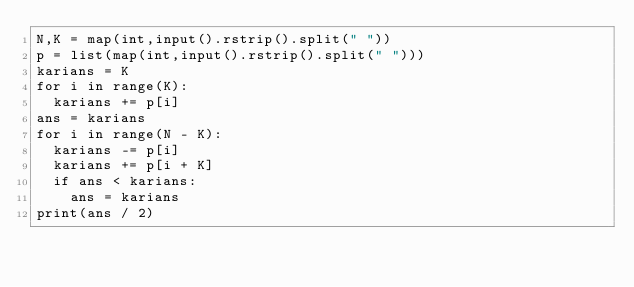<code> <loc_0><loc_0><loc_500><loc_500><_Python_>N,K = map(int,input().rstrip().split(" "))
p = list(map(int,input().rstrip().split(" ")))
karians = K
for i in range(K):
  karians += p[i]
ans = karians
for i in range(N - K):
  karians -= p[i]
  karians += p[i + K]
  if ans < karians:
    ans = karians
print(ans / 2)</code> 